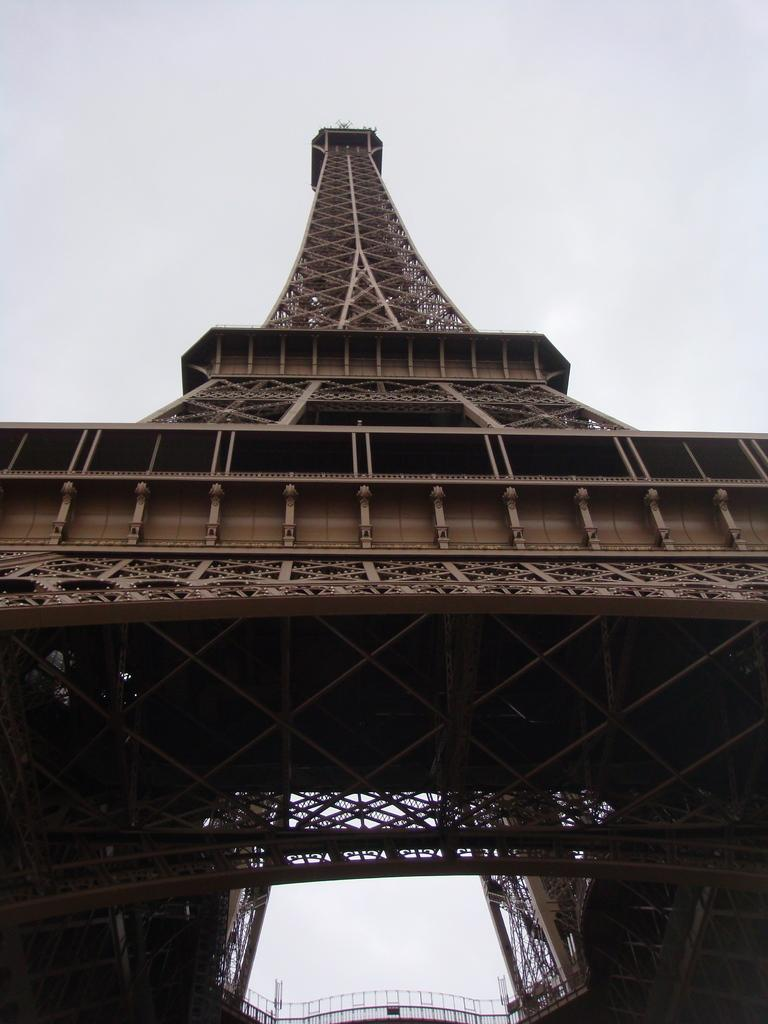What famous landmark is featured in the picture? There is an Eiffel tower in the picture. What can be seen in the background of the image? The sky is visible in the background of the picture. What type of bread is being baked in the camp in the image? There is no camp or bread present in the image; it features the Eiffel tower and the sky. 